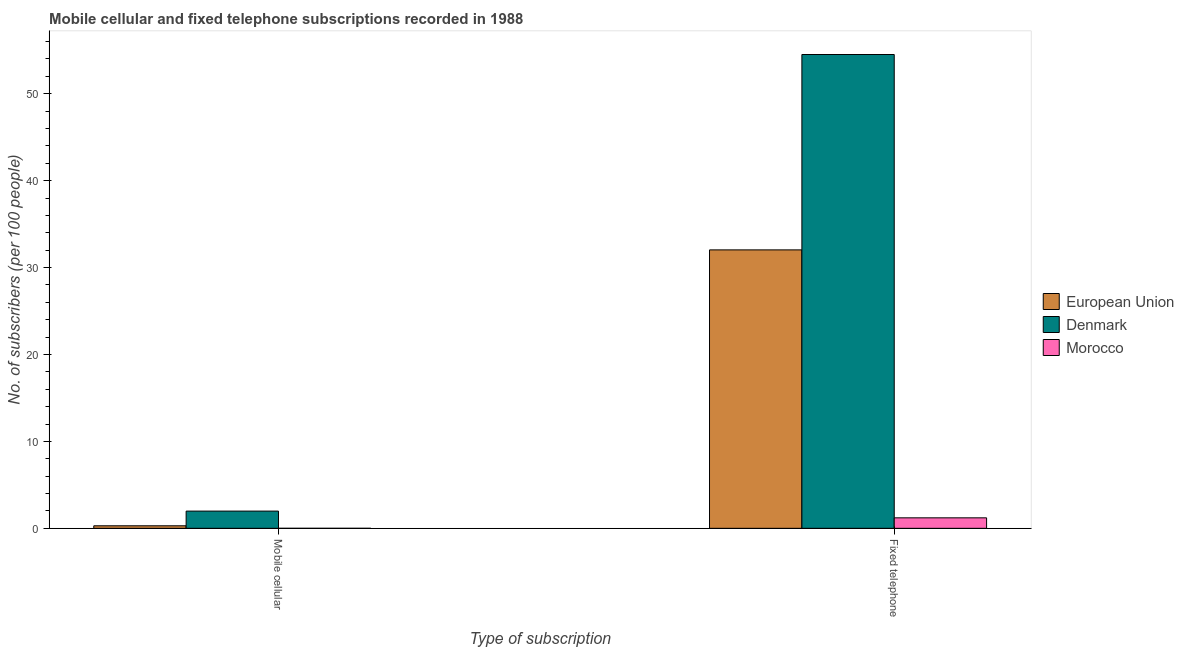How many groups of bars are there?
Offer a very short reply. 2. Are the number of bars per tick equal to the number of legend labels?
Provide a succinct answer. Yes. What is the label of the 2nd group of bars from the left?
Make the answer very short. Fixed telephone. What is the number of mobile cellular subscribers in Morocco?
Your answer should be very brief. 0. Across all countries, what is the maximum number of fixed telephone subscribers?
Provide a short and direct response. 54.51. Across all countries, what is the minimum number of fixed telephone subscribers?
Provide a succinct answer. 1.21. In which country was the number of fixed telephone subscribers minimum?
Give a very brief answer. Morocco. What is the total number of mobile cellular subscribers in the graph?
Your answer should be very brief. 2.27. What is the difference between the number of fixed telephone subscribers in European Union and that in Morocco?
Keep it short and to the point. 30.83. What is the difference between the number of fixed telephone subscribers in European Union and the number of mobile cellular subscribers in Denmark?
Keep it short and to the point. 30.05. What is the average number of fixed telephone subscribers per country?
Provide a succinct answer. 29.25. What is the difference between the number of fixed telephone subscribers and number of mobile cellular subscribers in Morocco?
Provide a short and direct response. 1.21. What is the ratio of the number of mobile cellular subscribers in Denmark to that in Morocco?
Give a very brief answer. 4479.91. Is the number of fixed telephone subscribers in Denmark less than that in Morocco?
Your response must be concise. No. What does the 3rd bar from the left in Mobile cellular represents?
Give a very brief answer. Morocco. How many countries are there in the graph?
Your answer should be very brief. 3. What is the difference between two consecutive major ticks on the Y-axis?
Make the answer very short. 10. Are the values on the major ticks of Y-axis written in scientific E-notation?
Make the answer very short. No. Does the graph contain any zero values?
Offer a terse response. No. What is the title of the graph?
Offer a very short reply. Mobile cellular and fixed telephone subscriptions recorded in 1988. What is the label or title of the X-axis?
Your response must be concise. Type of subscription. What is the label or title of the Y-axis?
Ensure brevity in your answer.  No. of subscribers (per 100 people). What is the No. of subscribers (per 100 people) of European Union in Mobile cellular?
Offer a terse response. 0.29. What is the No. of subscribers (per 100 people) in Denmark in Mobile cellular?
Make the answer very short. 1.98. What is the No. of subscribers (per 100 people) of Morocco in Mobile cellular?
Provide a short and direct response. 0. What is the No. of subscribers (per 100 people) in European Union in Fixed telephone?
Offer a terse response. 32.03. What is the No. of subscribers (per 100 people) in Denmark in Fixed telephone?
Provide a short and direct response. 54.51. What is the No. of subscribers (per 100 people) in Morocco in Fixed telephone?
Your answer should be compact. 1.21. Across all Type of subscription, what is the maximum No. of subscribers (per 100 people) in European Union?
Provide a short and direct response. 32.03. Across all Type of subscription, what is the maximum No. of subscribers (per 100 people) of Denmark?
Offer a very short reply. 54.51. Across all Type of subscription, what is the maximum No. of subscribers (per 100 people) in Morocco?
Your response must be concise. 1.21. Across all Type of subscription, what is the minimum No. of subscribers (per 100 people) in European Union?
Offer a very short reply. 0.29. Across all Type of subscription, what is the minimum No. of subscribers (per 100 people) of Denmark?
Your response must be concise. 1.98. Across all Type of subscription, what is the minimum No. of subscribers (per 100 people) of Morocco?
Give a very brief answer. 0. What is the total No. of subscribers (per 100 people) in European Union in the graph?
Offer a very short reply. 32.32. What is the total No. of subscribers (per 100 people) in Denmark in the graph?
Keep it short and to the point. 56.49. What is the total No. of subscribers (per 100 people) of Morocco in the graph?
Offer a very short reply. 1.21. What is the difference between the No. of subscribers (per 100 people) of European Union in Mobile cellular and that in Fixed telephone?
Your response must be concise. -31.74. What is the difference between the No. of subscribers (per 100 people) of Denmark in Mobile cellular and that in Fixed telephone?
Make the answer very short. -52.53. What is the difference between the No. of subscribers (per 100 people) of Morocco in Mobile cellular and that in Fixed telephone?
Give a very brief answer. -1.21. What is the difference between the No. of subscribers (per 100 people) in European Union in Mobile cellular and the No. of subscribers (per 100 people) in Denmark in Fixed telephone?
Your answer should be compact. -54.22. What is the difference between the No. of subscribers (per 100 people) of European Union in Mobile cellular and the No. of subscribers (per 100 people) of Morocco in Fixed telephone?
Offer a terse response. -0.92. What is the difference between the No. of subscribers (per 100 people) in Denmark in Mobile cellular and the No. of subscribers (per 100 people) in Morocco in Fixed telephone?
Provide a short and direct response. 0.77. What is the average No. of subscribers (per 100 people) of European Union per Type of subscription?
Offer a very short reply. 16.16. What is the average No. of subscribers (per 100 people) of Denmark per Type of subscription?
Offer a very short reply. 28.25. What is the average No. of subscribers (per 100 people) of Morocco per Type of subscription?
Give a very brief answer. 0.6. What is the difference between the No. of subscribers (per 100 people) of European Union and No. of subscribers (per 100 people) of Denmark in Mobile cellular?
Offer a very short reply. -1.69. What is the difference between the No. of subscribers (per 100 people) in European Union and No. of subscribers (per 100 people) in Morocco in Mobile cellular?
Make the answer very short. 0.29. What is the difference between the No. of subscribers (per 100 people) of Denmark and No. of subscribers (per 100 people) of Morocco in Mobile cellular?
Your answer should be compact. 1.98. What is the difference between the No. of subscribers (per 100 people) in European Union and No. of subscribers (per 100 people) in Denmark in Fixed telephone?
Offer a very short reply. -22.48. What is the difference between the No. of subscribers (per 100 people) in European Union and No. of subscribers (per 100 people) in Morocco in Fixed telephone?
Your answer should be compact. 30.83. What is the difference between the No. of subscribers (per 100 people) of Denmark and No. of subscribers (per 100 people) of Morocco in Fixed telephone?
Make the answer very short. 53.3. What is the ratio of the No. of subscribers (per 100 people) in European Union in Mobile cellular to that in Fixed telephone?
Give a very brief answer. 0.01. What is the ratio of the No. of subscribers (per 100 people) in Denmark in Mobile cellular to that in Fixed telephone?
Keep it short and to the point. 0.04. What is the ratio of the No. of subscribers (per 100 people) in Morocco in Mobile cellular to that in Fixed telephone?
Keep it short and to the point. 0. What is the difference between the highest and the second highest No. of subscribers (per 100 people) of European Union?
Offer a very short reply. 31.74. What is the difference between the highest and the second highest No. of subscribers (per 100 people) in Denmark?
Your answer should be very brief. 52.53. What is the difference between the highest and the second highest No. of subscribers (per 100 people) of Morocco?
Your response must be concise. 1.21. What is the difference between the highest and the lowest No. of subscribers (per 100 people) in European Union?
Offer a very short reply. 31.74. What is the difference between the highest and the lowest No. of subscribers (per 100 people) in Denmark?
Offer a terse response. 52.53. What is the difference between the highest and the lowest No. of subscribers (per 100 people) in Morocco?
Your answer should be very brief. 1.21. 